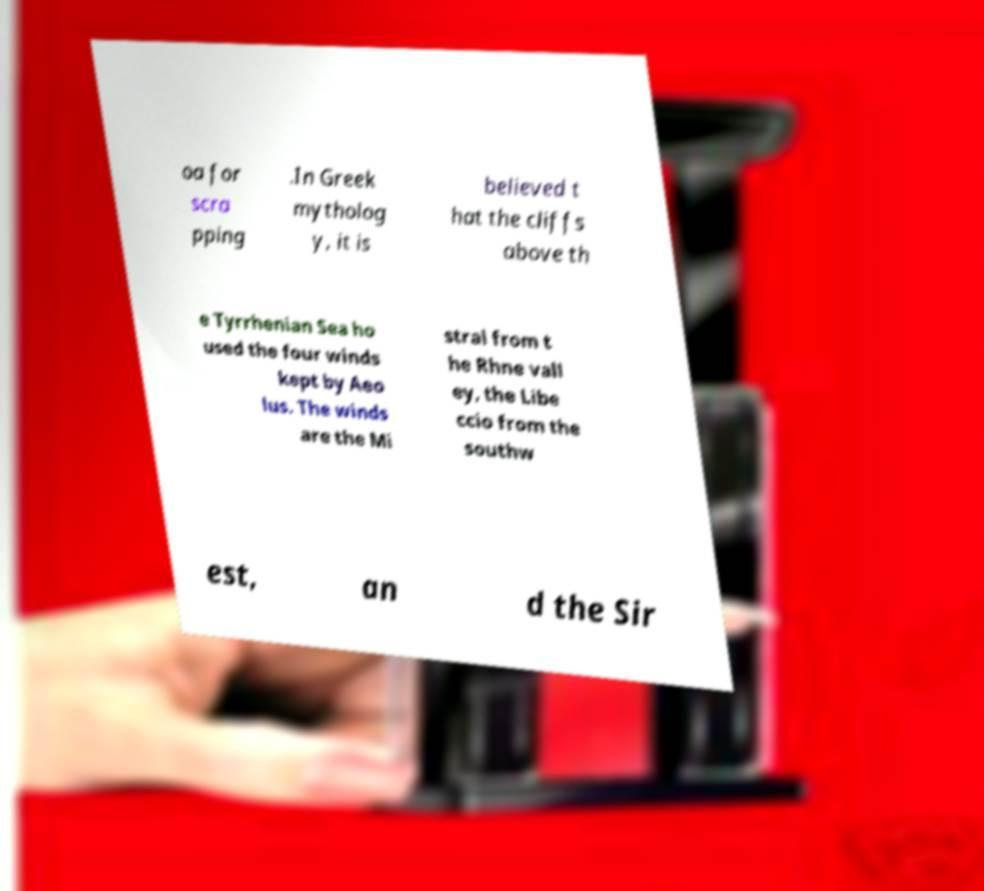Can you accurately transcribe the text from the provided image for me? oa for scra pping .In Greek mytholog y, it is believed t hat the cliffs above th e Tyrrhenian Sea ho used the four winds kept by Aeo lus. The winds are the Mi stral from t he Rhne vall ey, the Libe ccio from the southw est, an d the Sir 